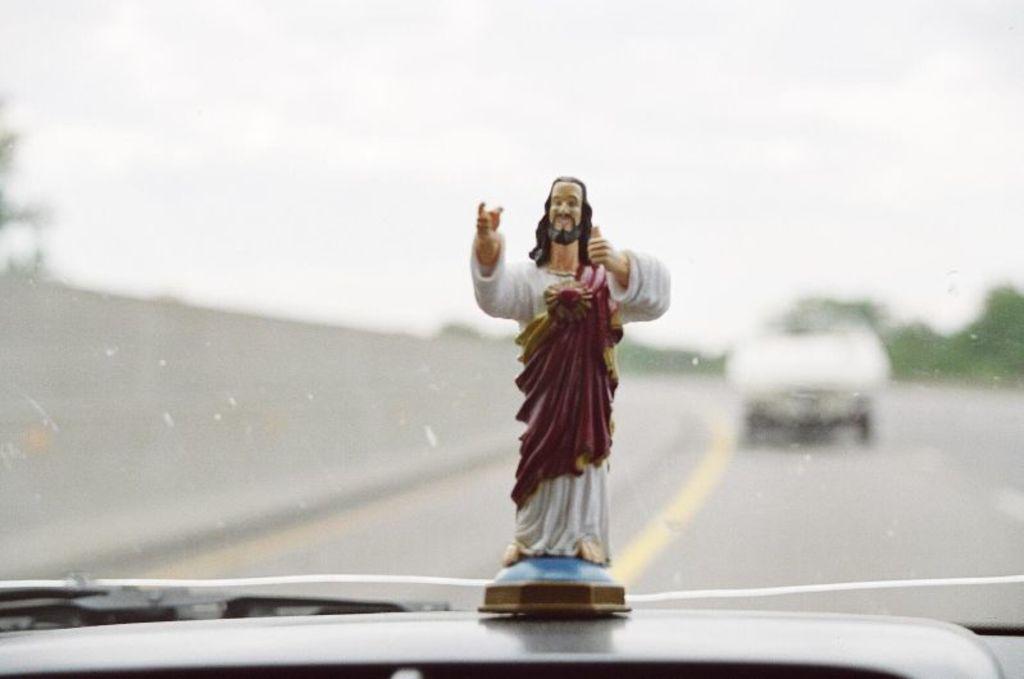What is the main subject in the front of the image? There is a statue in the front of the image. Can you describe the background of the image? The background of the image is blurry. What type of noise can be heard coming from the band in the image? There is no band present in the image, so it's not possible to determine what, if any, noise might be heard. 